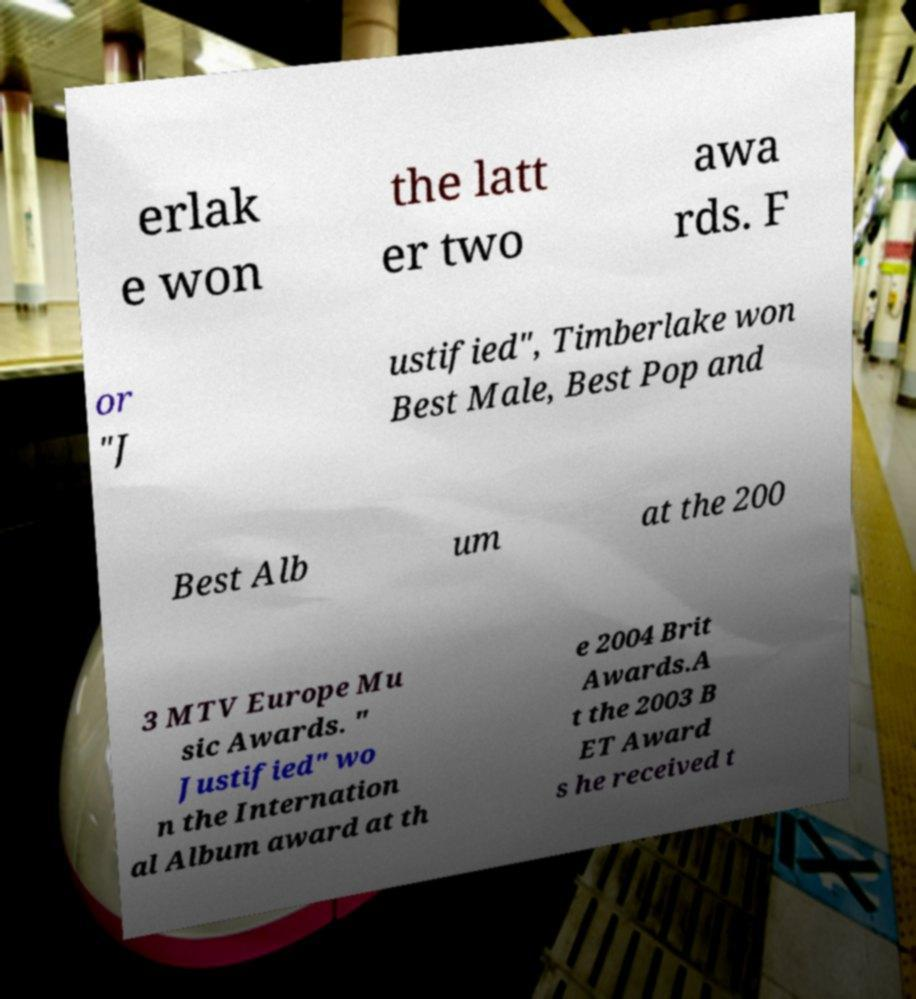Could you assist in decoding the text presented in this image and type it out clearly? erlak e won the latt er two awa rds. F or "J ustified", Timberlake won Best Male, Best Pop and Best Alb um at the 200 3 MTV Europe Mu sic Awards. " Justified" wo n the Internation al Album award at th e 2004 Brit Awards.A t the 2003 B ET Award s he received t 